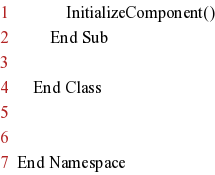<code> <loc_0><loc_0><loc_500><loc_500><_VisualBasic_>			InitializeComponent()
		End Sub

	End Class


End Namespace</code> 